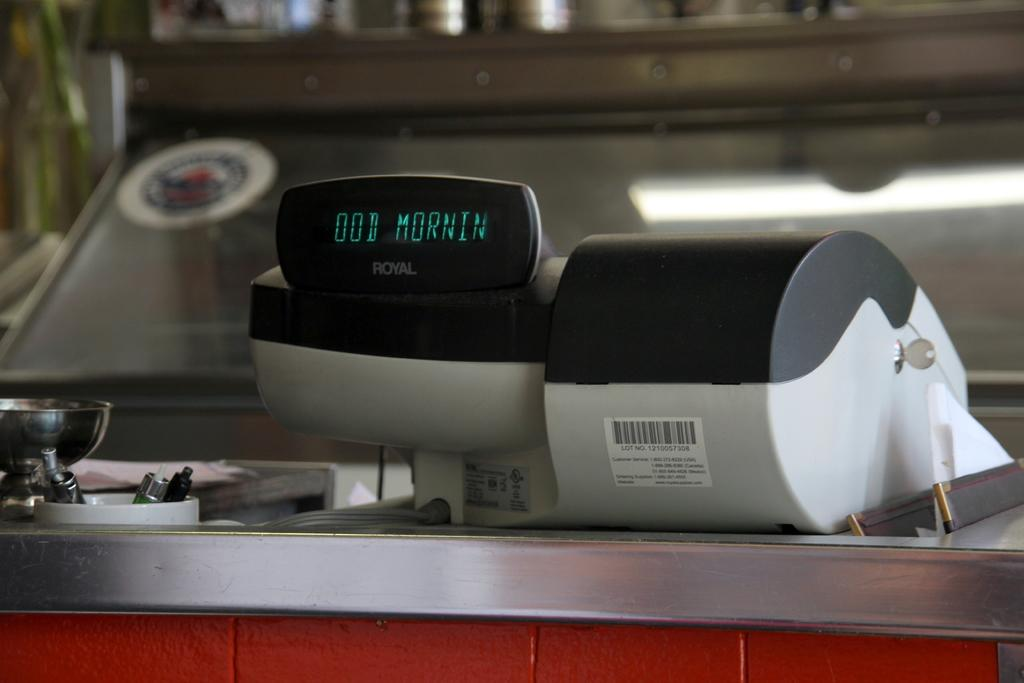<image>
Give a short and clear explanation of the subsequent image. A digital display on a piece of Royal equipment says good morning. 